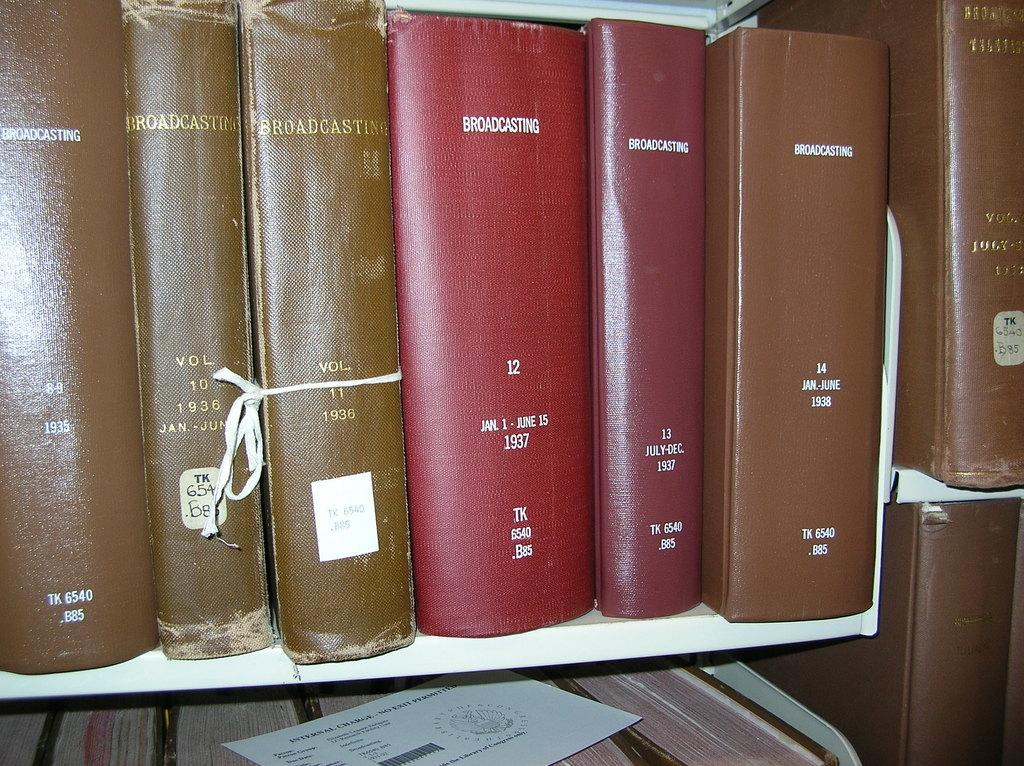<image>
Write a terse but informative summary of the picture. several Broadcasting books are lined up on a bookshelf 